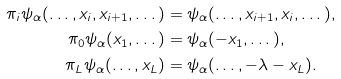<formula> <loc_0><loc_0><loc_500><loc_500>\pi _ { i } \psi _ { \alpha } ( \dots , x _ { i } , x _ { i + 1 } , \dots ) & = \psi _ { \alpha } ( \dots , x _ { i + 1 } , x _ { i } , \dots ) , \\ \pi _ { 0 } \psi _ { \alpha } ( x _ { 1 } , \dots ) & = \psi _ { \alpha } ( - x _ { 1 } , \dots ) , \\ \pi _ { L } \psi _ { \alpha } ( \dots , x _ { L } ) & = \psi _ { \alpha } ( \dots , - \lambda - x _ { L } ) .</formula> 